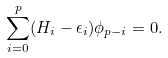Convert formula to latex. <formula><loc_0><loc_0><loc_500><loc_500>\sum _ { i = 0 } ^ { p } ( H _ { i } - \epsilon _ { i } ) \phi _ { p - i } = 0 .</formula> 